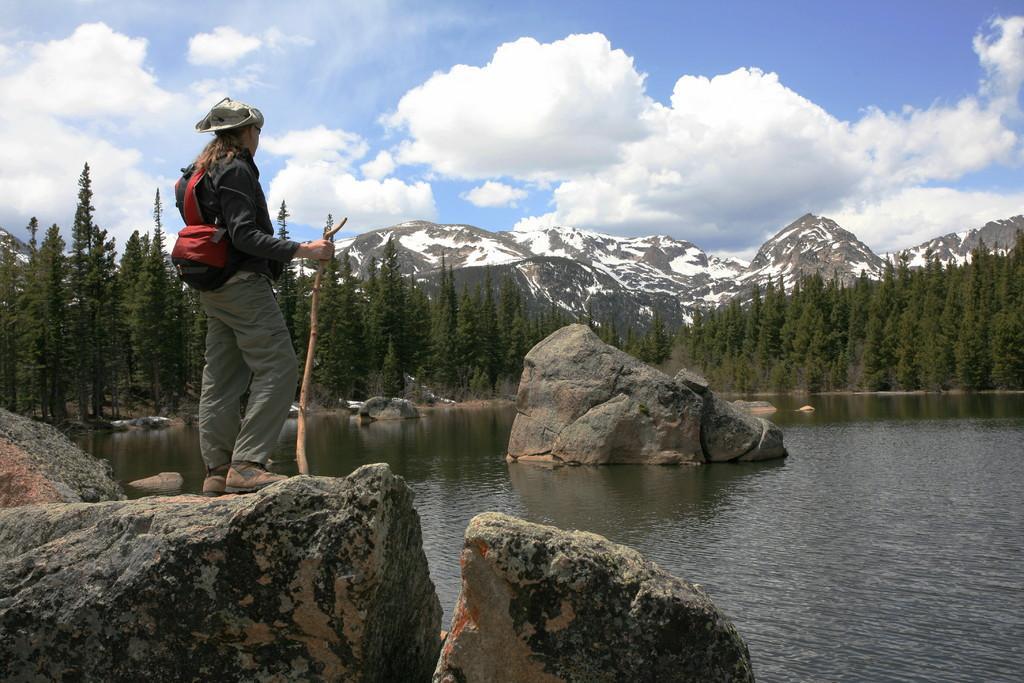Can you describe this image briefly? In the picture I can see a woman standing on the rock and she is on the left side. She is carrying a bag on her back and she is holding a wooden stick in her right hand. I can see the rocks and water on the right side. In the background, I can see the trees and mountains. There are clouds in the sky. 